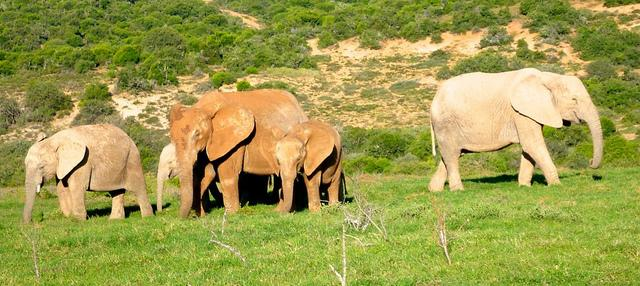What color is the elephant on the right? Please explain your reasoning. white. The color is white. 